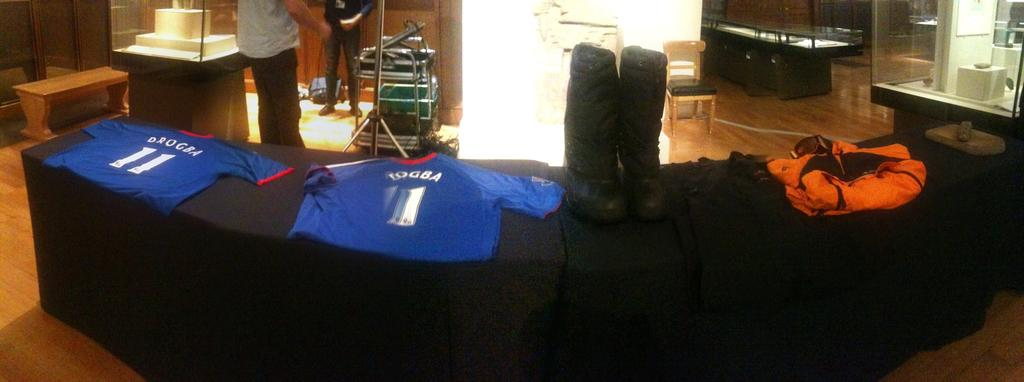<image>
Render a clear and concise summary of the photo. a display of clothing with a shirt saying DBOGEA 11 on it. 